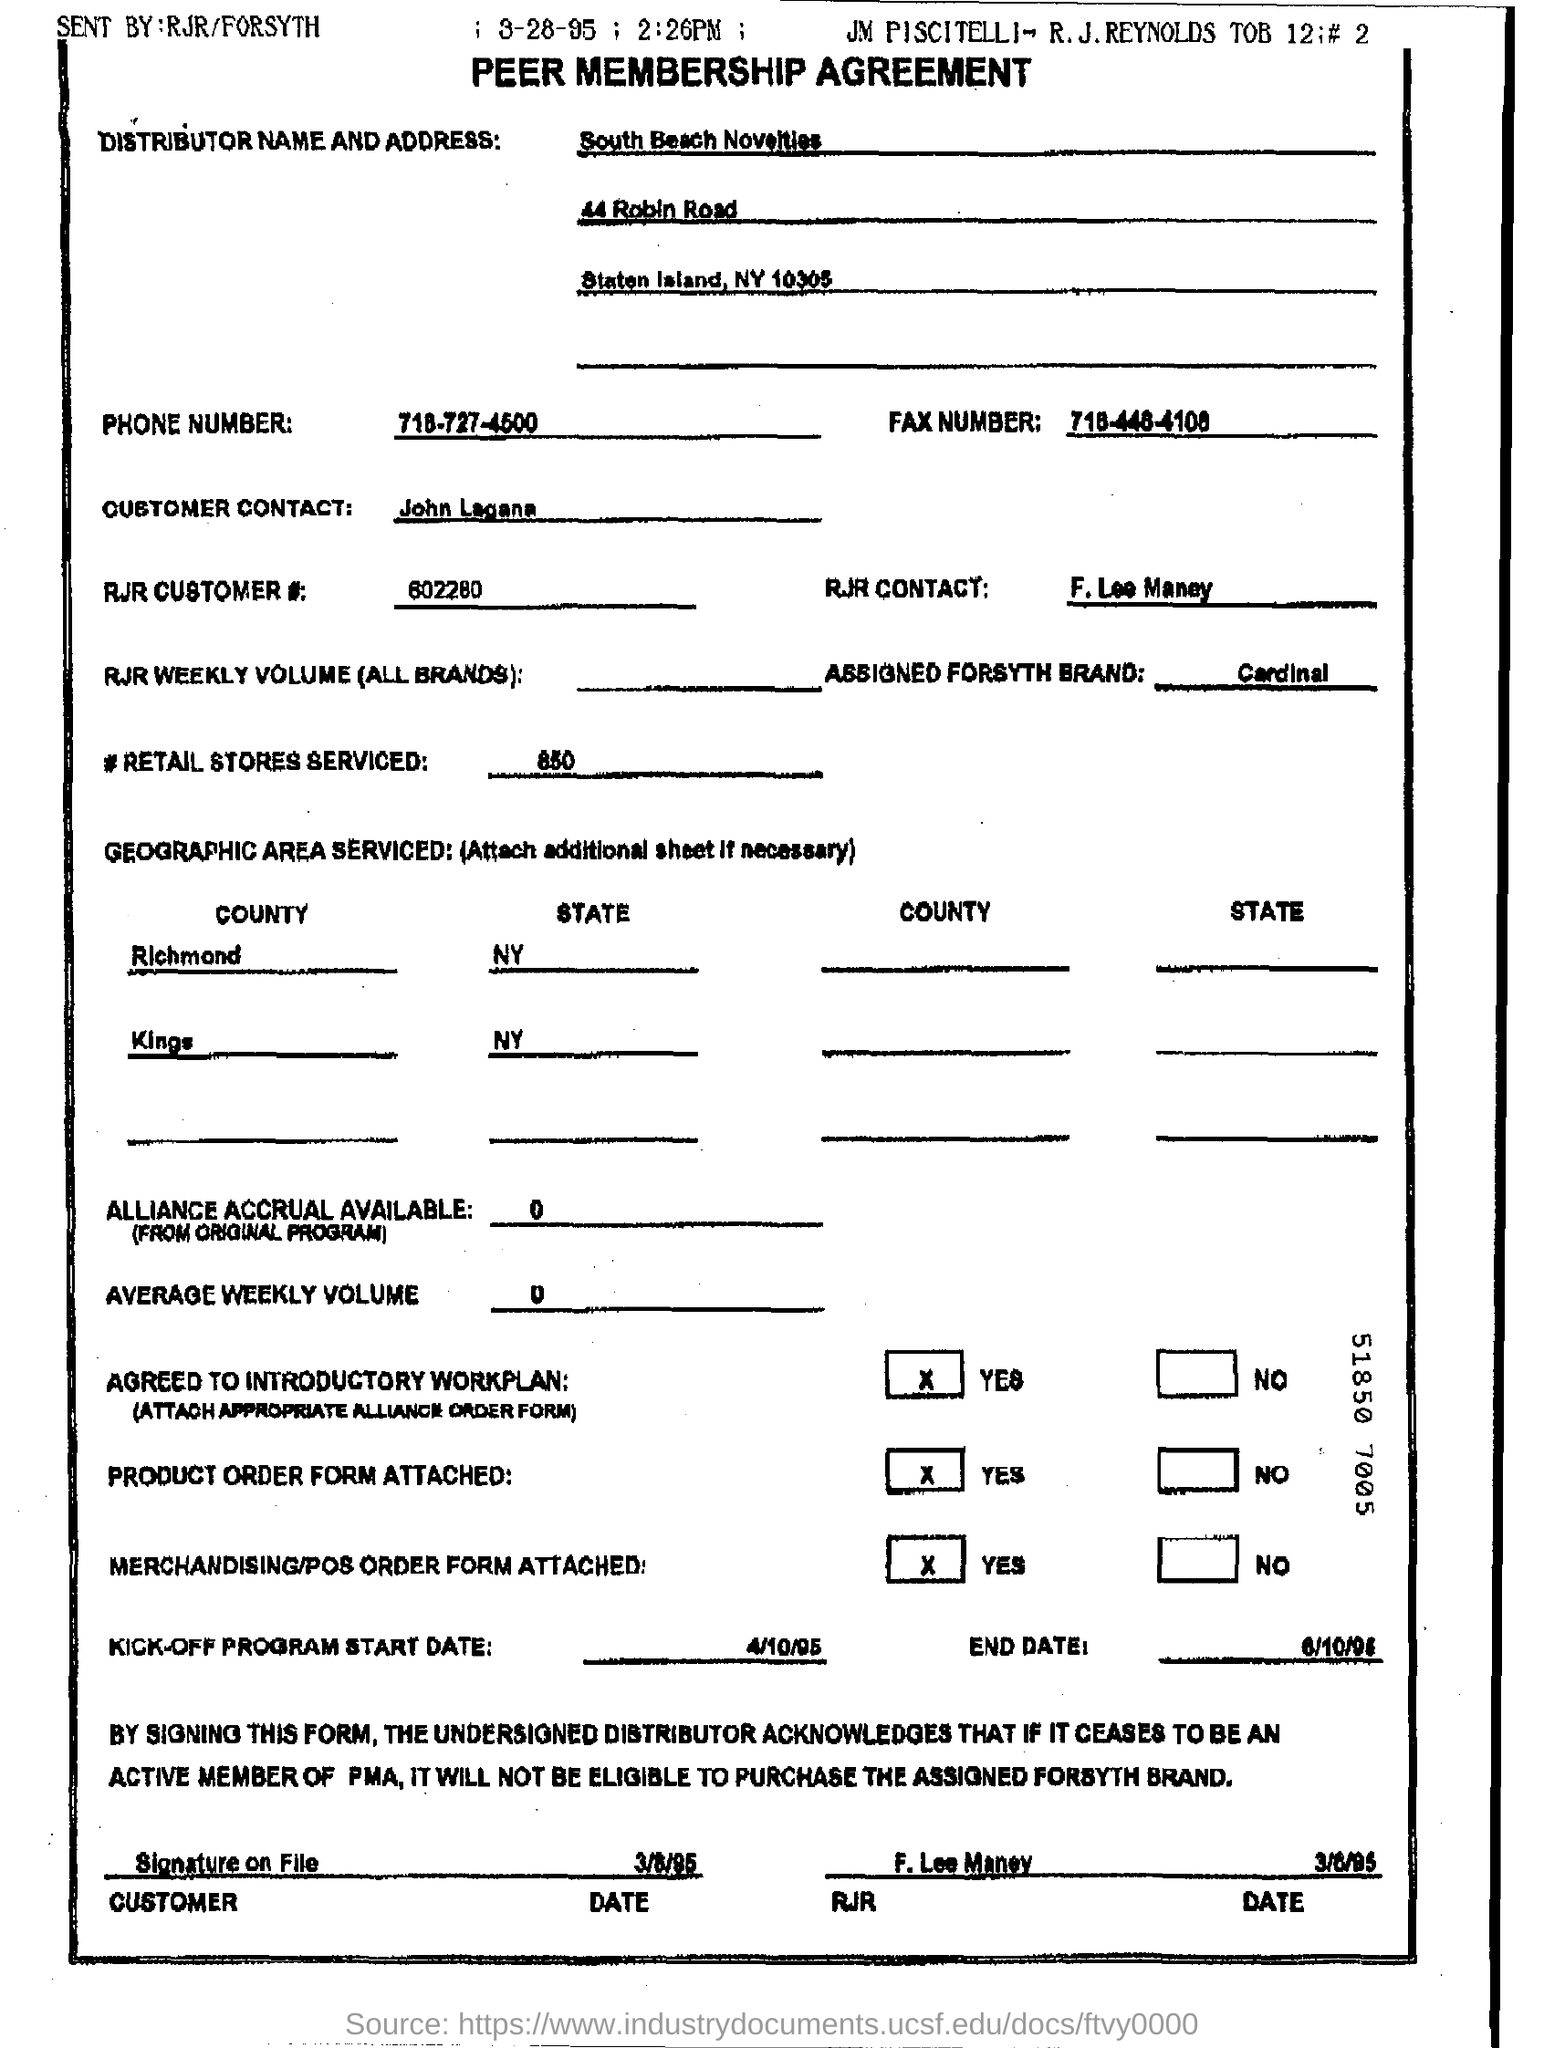Highlight a few significant elements in this photo. Eight hundred and fifty retail stores were served. The kick-off program is scheduled to begin on April 10, 1995. The agreement was sent by RJR/Forsyth. The distributor name is South Beach Novelties. The RJR customer number is 602280... 